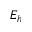<formula> <loc_0><loc_0><loc_500><loc_500>E _ { h }</formula> 